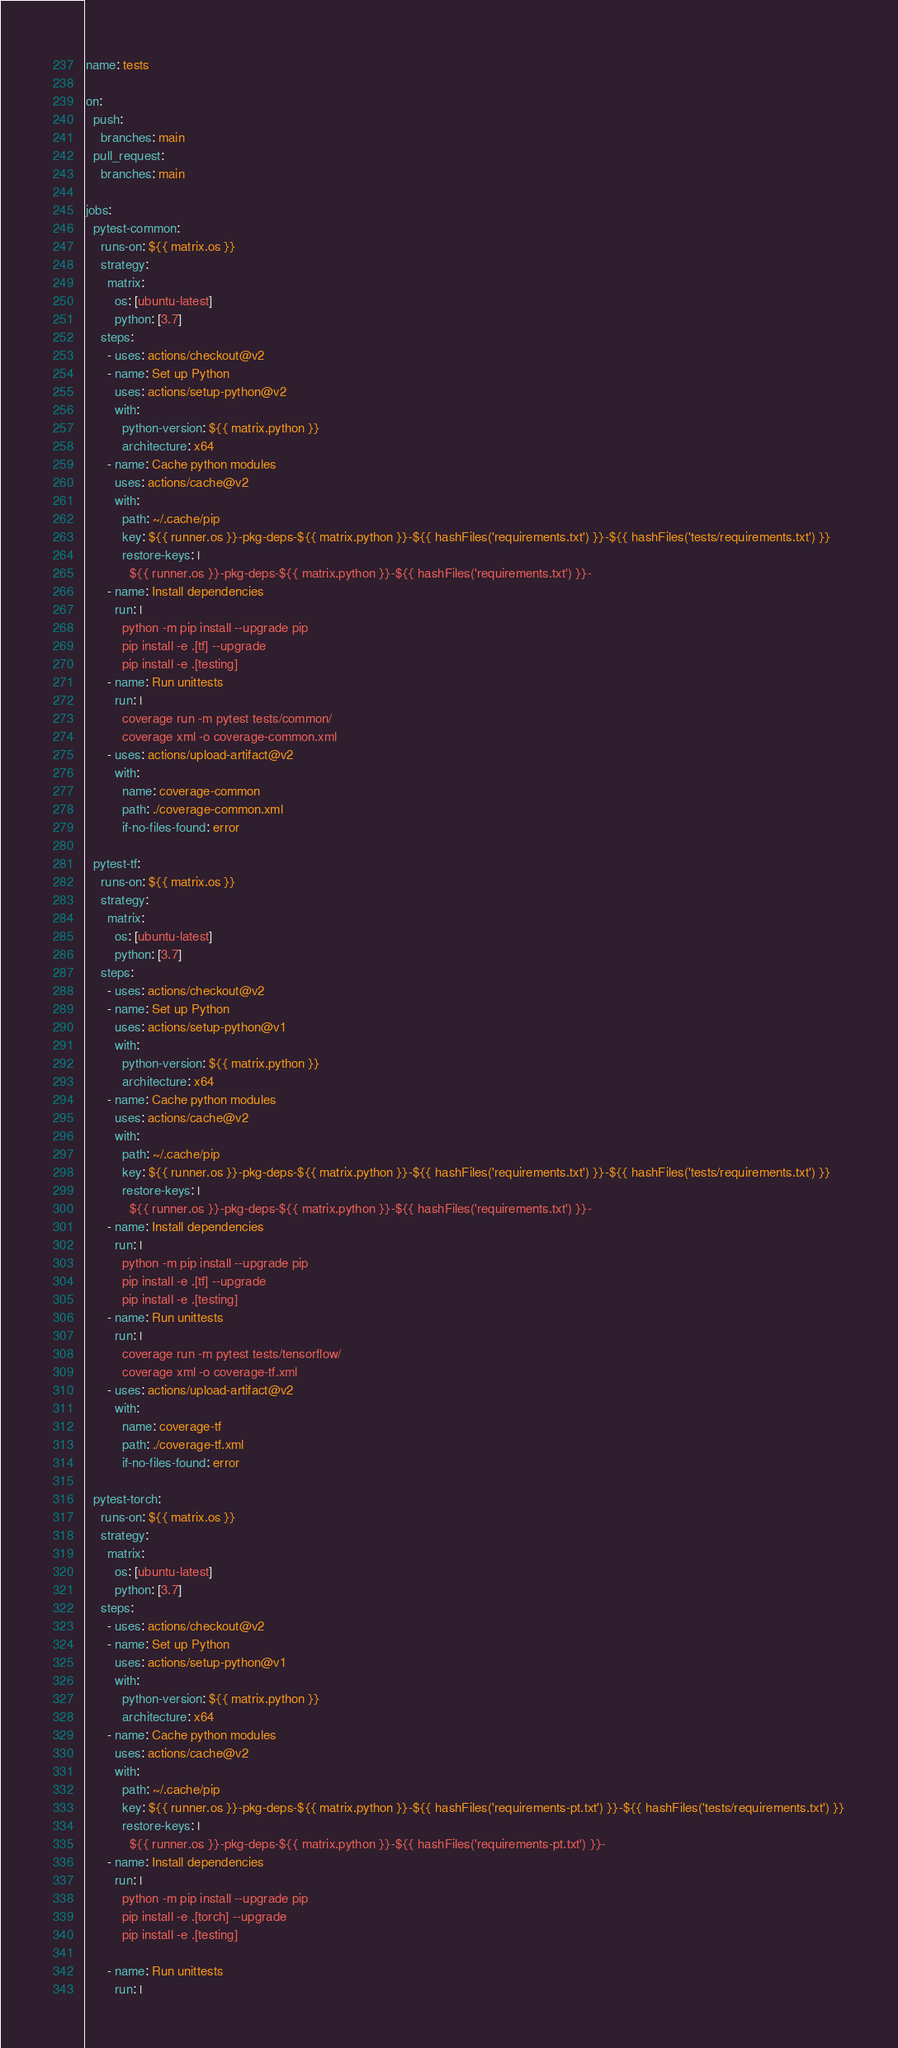<code> <loc_0><loc_0><loc_500><loc_500><_YAML_>name: tests

on:
  push:
    branches: main
  pull_request:
    branches: main

jobs:
  pytest-common:
    runs-on: ${{ matrix.os }}
    strategy:
      matrix:
        os: [ubuntu-latest]
        python: [3.7]
    steps:
      - uses: actions/checkout@v2
      - name: Set up Python
        uses: actions/setup-python@v2
        with:
          python-version: ${{ matrix.python }}
          architecture: x64
      - name: Cache python modules
        uses: actions/cache@v2
        with:
          path: ~/.cache/pip
          key: ${{ runner.os }}-pkg-deps-${{ matrix.python }}-${{ hashFiles('requirements.txt') }}-${{ hashFiles('tests/requirements.txt') }}
          restore-keys: |
            ${{ runner.os }}-pkg-deps-${{ matrix.python }}-${{ hashFiles('requirements.txt') }}-
      - name: Install dependencies
        run: |
          python -m pip install --upgrade pip
          pip install -e .[tf] --upgrade
          pip install -e .[testing]
      - name: Run unittests
        run: |
          coverage run -m pytest tests/common/
          coverage xml -o coverage-common.xml
      - uses: actions/upload-artifact@v2
        with:
          name: coverage-common
          path: ./coverage-common.xml
          if-no-files-found: error

  pytest-tf:
    runs-on: ${{ matrix.os }}
    strategy:
      matrix:
        os: [ubuntu-latest]
        python: [3.7]
    steps:
      - uses: actions/checkout@v2
      - name: Set up Python
        uses: actions/setup-python@v1
        with:
          python-version: ${{ matrix.python }}
          architecture: x64
      - name: Cache python modules
        uses: actions/cache@v2
        with:
          path: ~/.cache/pip
          key: ${{ runner.os }}-pkg-deps-${{ matrix.python }}-${{ hashFiles('requirements.txt') }}-${{ hashFiles('tests/requirements.txt') }}
          restore-keys: |
            ${{ runner.os }}-pkg-deps-${{ matrix.python }}-${{ hashFiles('requirements.txt') }}-
      - name: Install dependencies
        run: |
          python -m pip install --upgrade pip
          pip install -e .[tf] --upgrade
          pip install -e .[testing]
      - name: Run unittests
        run: |
          coverage run -m pytest tests/tensorflow/
          coverage xml -o coverage-tf.xml
      - uses: actions/upload-artifact@v2
        with:
          name: coverage-tf
          path: ./coverage-tf.xml
          if-no-files-found: error

  pytest-torch:
    runs-on: ${{ matrix.os }}
    strategy:
      matrix:
        os: [ubuntu-latest]
        python: [3.7]
    steps:
      - uses: actions/checkout@v2
      - name: Set up Python
        uses: actions/setup-python@v1
        with:
          python-version: ${{ matrix.python }}
          architecture: x64
      - name: Cache python modules
        uses: actions/cache@v2
        with:
          path: ~/.cache/pip
          key: ${{ runner.os }}-pkg-deps-${{ matrix.python }}-${{ hashFiles('requirements-pt.txt') }}-${{ hashFiles('tests/requirements.txt') }}
          restore-keys: |
            ${{ runner.os }}-pkg-deps-${{ matrix.python }}-${{ hashFiles('requirements-pt.txt') }}-
      - name: Install dependencies
        run: |
          python -m pip install --upgrade pip
          pip install -e .[torch] --upgrade
          pip install -e .[testing]

      - name: Run unittests
        run: |</code> 